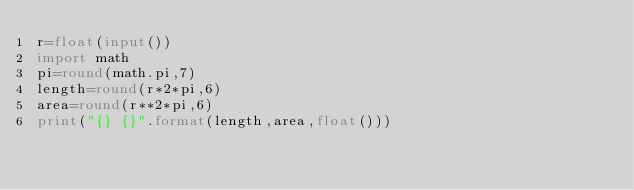<code> <loc_0><loc_0><loc_500><loc_500><_Python_>r=float(input())
import math
pi=round(math.pi,7)
length=round(r*2*pi,6)
area=round(r**2*pi,6)
print("{} {}".format(length,area,float()))
</code> 